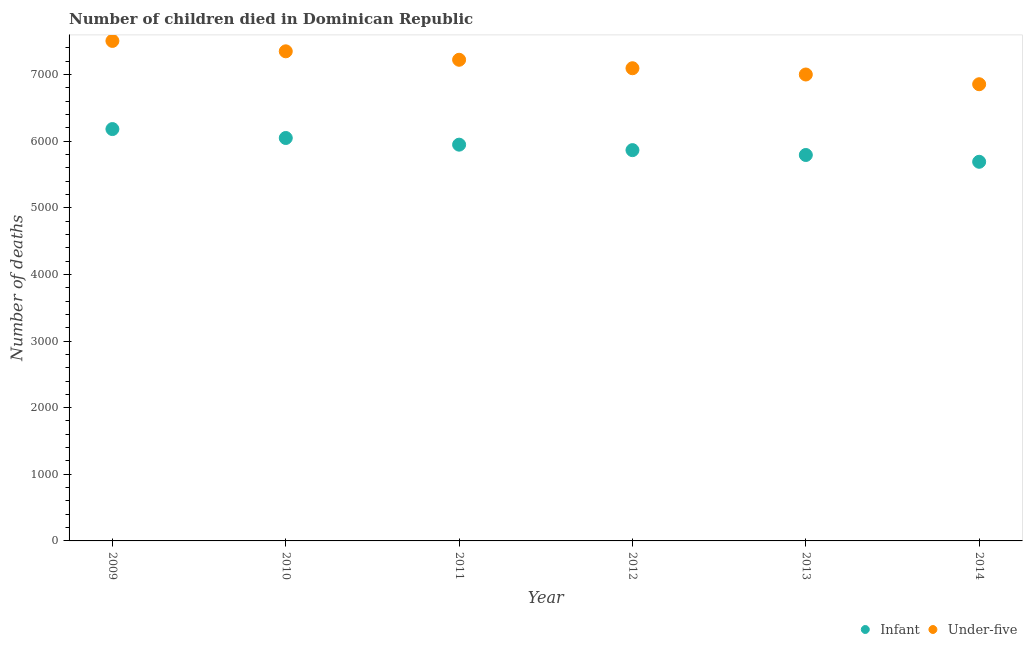How many different coloured dotlines are there?
Ensure brevity in your answer.  2. What is the number of infant deaths in 2010?
Your answer should be very brief. 6047. Across all years, what is the maximum number of infant deaths?
Provide a succinct answer. 6181. Across all years, what is the minimum number of infant deaths?
Ensure brevity in your answer.  5690. What is the total number of under-five deaths in the graph?
Keep it short and to the point. 4.30e+04. What is the difference between the number of infant deaths in 2012 and that in 2013?
Ensure brevity in your answer.  73. What is the difference between the number of infant deaths in 2010 and the number of under-five deaths in 2014?
Your response must be concise. -807. What is the average number of under-five deaths per year?
Make the answer very short. 7170.17. In the year 2009, what is the difference between the number of infant deaths and number of under-five deaths?
Your answer should be compact. -1323. In how many years, is the number of under-five deaths greater than 4400?
Provide a short and direct response. 6. What is the ratio of the number of infant deaths in 2009 to that in 2013?
Offer a terse response. 1.07. What is the difference between the highest and the second highest number of under-five deaths?
Ensure brevity in your answer.  156. What is the difference between the highest and the lowest number of infant deaths?
Offer a very short reply. 491. In how many years, is the number of infant deaths greater than the average number of infant deaths taken over all years?
Provide a succinct answer. 3. Is the sum of the number of under-five deaths in 2009 and 2012 greater than the maximum number of infant deaths across all years?
Your response must be concise. Yes. Does the number of infant deaths monotonically increase over the years?
Give a very brief answer. No. Is the number of under-five deaths strictly greater than the number of infant deaths over the years?
Provide a succinct answer. Yes. Is the number of under-five deaths strictly less than the number of infant deaths over the years?
Ensure brevity in your answer.  No. What is the difference between two consecutive major ticks on the Y-axis?
Provide a succinct answer. 1000. Are the values on the major ticks of Y-axis written in scientific E-notation?
Your response must be concise. No. Does the graph contain any zero values?
Provide a succinct answer. No. Where does the legend appear in the graph?
Provide a succinct answer. Bottom right. How many legend labels are there?
Provide a short and direct response. 2. What is the title of the graph?
Make the answer very short. Number of children died in Dominican Republic. Does "Resident" appear as one of the legend labels in the graph?
Provide a succinct answer. No. What is the label or title of the X-axis?
Offer a terse response. Year. What is the label or title of the Y-axis?
Ensure brevity in your answer.  Number of deaths. What is the Number of deaths of Infant in 2009?
Provide a succinct answer. 6181. What is the Number of deaths of Under-five in 2009?
Provide a succinct answer. 7504. What is the Number of deaths of Infant in 2010?
Provide a succinct answer. 6047. What is the Number of deaths in Under-five in 2010?
Make the answer very short. 7348. What is the Number of deaths in Infant in 2011?
Ensure brevity in your answer.  5947. What is the Number of deaths of Under-five in 2011?
Keep it short and to the point. 7221. What is the Number of deaths in Infant in 2012?
Give a very brief answer. 5865. What is the Number of deaths of Under-five in 2012?
Your answer should be very brief. 7094. What is the Number of deaths of Infant in 2013?
Offer a very short reply. 5792. What is the Number of deaths in Under-five in 2013?
Keep it short and to the point. 7000. What is the Number of deaths in Infant in 2014?
Provide a succinct answer. 5690. What is the Number of deaths in Under-five in 2014?
Provide a short and direct response. 6854. Across all years, what is the maximum Number of deaths in Infant?
Keep it short and to the point. 6181. Across all years, what is the maximum Number of deaths in Under-five?
Make the answer very short. 7504. Across all years, what is the minimum Number of deaths in Infant?
Offer a very short reply. 5690. Across all years, what is the minimum Number of deaths in Under-five?
Make the answer very short. 6854. What is the total Number of deaths in Infant in the graph?
Your answer should be compact. 3.55e+04. What is the total Number of deaths of Under-five in the graph?
Provide a succinct answer. 4.30e+04. What is the difference between the Number of deaths in Infant in 2009 and that in 2010?
Your answer should be very brief. 134. What is the difference between the Number of deaths in Under-five in 2009 and that in 2010?
Make the answer very short. 156. What is the difference between the Number of deaths of Infant in 2009 and that in 2011?
Ensure brevity in your answer.  234. What is the difference between the Number of deaths in Under-five in 2009 and that in 2011?
Give a very brief answer. 283. What is the difference between the Number of deaths in Infant in 2009 and that in 2012?
Your answer should be compact. 316. What is the difference between the Number of deaths in Under-five in 2009 and that in 2012?
Provide a succinct answer. 410. What is the difference between the Number of deaths of Infant in 2009 and that in 2013?
Your answer should be compact. 389. What is the difference between the Number of deaths of Under-five in 2009 and that in 2013?
Give a very brief answer. 504. What is the difference between the Number of deaths in Infant in 2009 and that in 2014?
Make the answer very short. 491. What is the difference between the Number of deaths of Under-five in 2009 and that in 2014?
Offer a very short reply. 650. What is the difference between the Number of deaths of Under-five in 2010 and that in 2011?
Ensure brevity in your answer.  127. What is the difference between the Number of deaths of Infant in 2010 and that in 2012?
Offer a terse response. 182. What is the difference between the Number of deaths in Under-five in 2010 and that in 2012?
Your answer should be compact. 254. What is the difference between the Number of deaths in Infant in 2010 and that in 2013?
Provide a short and direct response. 255. What is the difference between the Number of deaths in Under-five in 2010 and that in 2013?
Ensure brevity in your answer.  348. What is the difference between the Number of deaths of Infant in 2010 and that in 2014?
Your answer should be very brief. 357. What is the difference between the Number of deaths in Under-five in 2010 and that in 2014?
Provide a succinct answer. 494. What is the difference between the Number of deaths of Under-five in 2011 and that in 2012?
Offer a very short reply. 127. What is the difference between the Number of deaths in Infant in 2011 and that in 2013?
Make the answer very short. 155. What is the difference between the Number of deaths of Under-five in 2011 and that in 2013?
Provide a short and direct response. 221. What is the difference between the Number of deaths of Infant in 2011 and that in 2014?
Offer a terse response. 257. What is the difference between the Number of deaths of Under-five in 2011 and that in 2014?
Your answer should be very brief. 367. What is the difference between the Number of deaths of Under-five in 2012 and that in 2013?
Make the answer very short. 94. What is the difference between the Number of deaths in Infant in 2012 and that in 2014?
Your response must be concise. 175. What is the difference between the Number of deaths in Under-five in 2012 and that in 2014?
Provide a short and direct response. 240. What is the difference between the Number of deaths of Infant in 2013 and that in 2014?
Provide a short and direct response. 102. What is the difference between the Number of deaths in Under-five in 2013 and that in 2014?
Your answer should be very brief. 146. What is the difference between the Number of deaths of Infant in 2009 and the Number of deaths of Under-five in 2010?
Offer a very short reply. -1167. What is the difference between the Number of deaths in Infant in 2009 and the Number of deaths in Under-five in 2011?
Ensure brevity in your answer.  -1040. What is the difference between the Number of deaths of Infant in 2009 and the Number of deaths of Under-five in 2012?
Your answer should be compact. -913. What is the difference between the Number of deaths in Infant in 2009 and the Number of deaths in Under-five in 2013?
Offer a very short reply. -819. What is the difference between the Number of deaths in Infant in 2009 and the Number of deaths in Under-five in 2014?
Your answer should be compact. -673. What is the difference between the Number of deaths of Infant in 2010 and the Number of deaths of Under-five in 2011?
Make the answer very short. -1174. What is the difference between the Number of deaths in Infant in 2010 and the Number of deaths in Under-five in 2012?
Provide a succinct answer. -1047. What is the difference between the Number of deaths of Infant in 2010 and the Number of deaths of Under-five in 2013?
Offer a very short reply. -953. What is the difference between the Number of deaths in Infant in 2010 and the Number of deaths in Under-five in 2014?
Your answer should be compact. -807. What is the difference between the Number of deaths in Infant in 2011 and the Number of deaths in Under-five in 2012?
Keep it short and to the point. -1147. What is the difference between the Number of deaths in Infant in 2011 and the Number of deaths in Under-five in 2013?
Your response must be concise. -1053. What is the difference between the Number of deaths in Infant in 2011 and the Number of deaths in Under-five in 2014?
Provide a short and direct response. -907. What is the difference between the Number of deaths of Infant in 2012 and the Number of deaths of Under-five in 2013?
Your answer should be compact. -1135. What is the difference between the Number of deaths of Infant in 2012 and the Number of deaths of Under-five in 2014?
Your answer should be compact. -989. What is the difference between the Number of deaths of Infant in 2013 and the Number of deaths of Under-five in 2014?
Give a very brief answer. -1062. What is the average Number of deaths in Infant per year?
Your answer should be compact. 5920.33. What is the average Number of deaths of Under-five per year?
Offer a terse response. 7170.17. In the year 2009, what is the difference between the Number of deaths in Infant and Number of deaths in Under-five?
Give a very brief answer. -1323. In the year 2010, what is the difference between the Number of deaths in Infant and Number of deaths in Under-five?
Offer a terse response. -1301. In the year 2011, what is the difference between the Number of deaths of Infant and Number of deaths of Under-five?
Your answer should be very brief. -1274. In the year 2012, what is the difference between the Number of deaths of Infant and Number of deaths of Under-five?
Keep it short and to the point. -1229. In the year 2013, what is the difference between the Number of deaths in Infant and Number of deaths in Under-five?
Provide a short and direct response. -1208. In the year 2014, what is the difference between the Number of deaths in Infant and Number of deaths in Under-five?
Offer a very short reply. -1164. What is the ratio of the Number of deaths in Infant in 2009 to that in 2010?
Keep it short and to the point. 1.02. What is the ratio of the Number of deaths of Under-five in 2009 to that in 2010?
Provide a short and direct response. 1.02. What is the ratio of the Number of deaths of Infant in 2009 to that in 2011?
Keep it short and to the point. 1.04. What is the ratio of the Number of deaths of Under-five in 2009 to that in 2011?
Keep it short and to the point. 1.04. What is the ratio of the Number of deaths in Infant in 2009 to that in 2012?
Make the answer very short. 1.05. What is the ratio of the Number of deaths of Under-five in 2009 to that in 2012?
Your answer should be very brief. 1.06. What is the ratio of the Number of deaths in Infant in 2009 to that in 2013?
Provide a short and direct response. 1.07. What is the ratio of the Number of deaths in Under-five in 2009 to that in 2013?
Your answer should be compact. 1.07. What is the ratio of the Number of deaths of Infant in 2009 to that in 2014?
Give a very brief answer. 1.09. What is the ratio of the Number of deaths in Under-five in 2009 to that in 2014?
Your answer should be compact. 1.09. What is the ratio of the Number of deaths in Infant in 2010 to that in 2011?
Make the answer very short. 1.02. What is the ratio of the Number of deaths in Under-five in 2010 to that in 2011?
Offer a terse response. 1.02. What is the ratio of the Number of deaths of Infant in 2010 to that in 2012?
Make the answer very short. 1.03. What is the ratio of the Number of deaths of Under-five in 2010 to that in 2012?
Ensure brevity in your answer.  1.04. What is the ratio of the Number of deaths in Infant in 2010 to that in 2013?
Ensure brevity in your answer.  1.04. What is the ratio of the Number of deaths of Under-five in 2010 to that in 2013?
Offer a terse response. 1.05. What is the ratio of the Number of deaths in Infant in 2010 to that in 2014?
Provide a short and direct response. 1.06. What is the ratio of the Number of deaths in Under-five in 2010 to that in 2014?
Ensure brevity in your answer.  1.07. What is the ratio of the Number of deaths in Infant in 2011 to that in 2012?
Provide a succinct answer. 1.01. What is the ratio of the Number of deaths of Under-five in 2011 to that in 2012?
Provide a succinct answer. 1.02. What is the ratio of the Number of deaths in Infant in 2011 to that in 2013?
Keep it short and to the point. 1.03. What is the ratio of the Number of deaths of Under-five in 2011 to that in 2013?
Ensure brevity in your answer.  1.03. What is the ratio of the Number of deaths in Infant in 2011 to that in 2014?
Keep it short and to the point. 1.05. What is the ratio of the Number of deaths in Under-five in 2011 to that in 2014?
Your response must be concise. 1.05. What is the ratio of the Number of deaths of Infant in 2012 to that in 2013?
Provide a short and direct response. 1.01. What is the ratio of the Number of deaths in Under-five in 2012 to that in 2013?
Ensure brevity in your answer.  1.01. What is the ratio of the Number of deaths in Infant in 2012 to that in 2014?
Give a very brief answer. 1.03. What is the ratio of the Number of deaths in Under-five in 2012 to that in 2014?
Make the answer very short. 1.03. What is the ratio of the Number of deaths of Infant in 2013 to that in 2014?
Keep it short and to the point. 1.02. What is the ratio of the Number of deaths in Under-five in 2013 to that in 2014?
Offer a very short reply. 1.02. What is the difference between the highest and the second highest Number of deaths of Infant?
Your answer should be compact. 134. What is the difference between the highest and the second highest Number of deaths of Under-five?
Your answer should be compact. 156. What is the difference between the highest and the lowest Number of deaths in Infant?
Make the answer very short. 491. What is the difference between the highest and the lowest Number of deaths in Under-five?
Give a very brief answer. 650. 